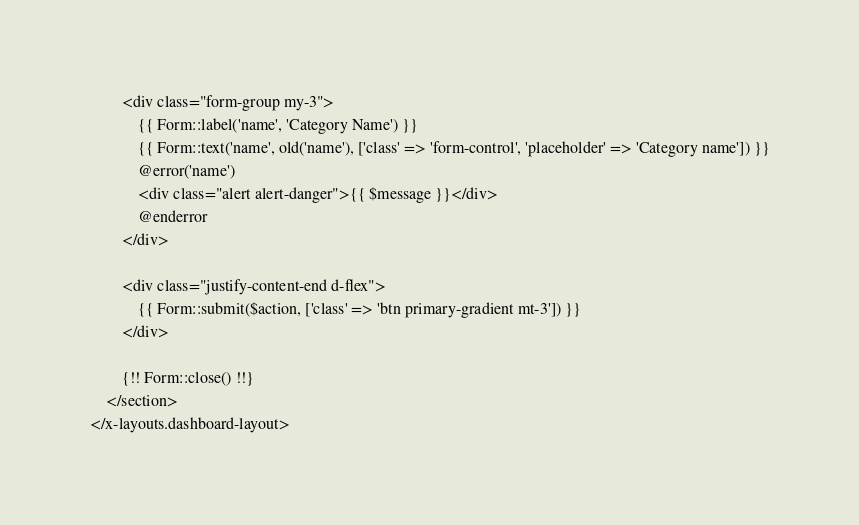<code> <loc_0><loc_0><loc_500><loc_500><_PHP_>
        <div class="form-group my-3">
            {{ Form::label('name', 'Category Name') }}
            {{ Form::text('name', old('name'), ['class' => 'form-control', 'placeholder' => 'Category name']) }}
            @error('name')
            <div class="alert alert-danger">{{ $message }}</div>
            @enderror
        </div>

        <div class="justify-content-end d-flex">
            {{ Form::submit($action, ['class' => 'btn primary-gradient mt-3']) }}
        </div>

        {!! Form::close() !!}
    </section>
</x-layouts.dashboard-layout>
</code> 